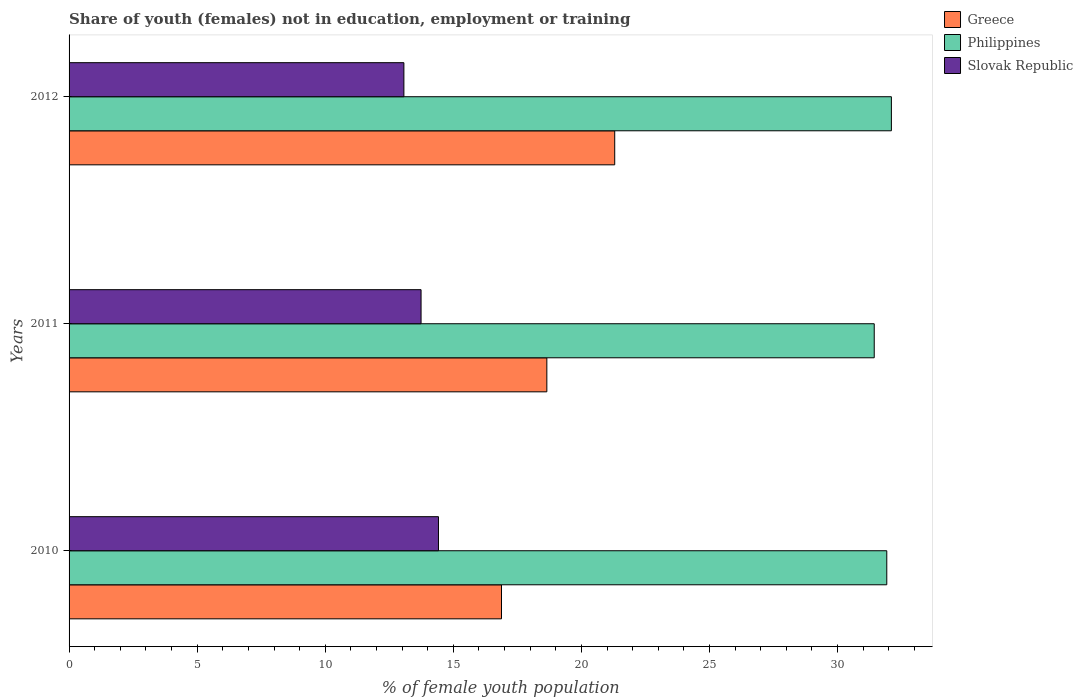How many groups of bars are there?
Make the answer very short. 3. Are the number of bars per tick equal to the number of legend labels?
Ensure brevity in your answer.  Yes. How many bars are there on the 3rd tick from the top?
Offer a very short reply. 3. How many bars are there on the 1st tick from the bottom?
Your answer should be compact. 3. In how many cases, is the number of bars for a given year not equal to the number of legend labels?
Provide a short and direct response. 0. What is the percentage of unemployed female population in in Slovak Republic in 2010?
Give a very brief answer. 14.42. Across all years, what is the maximum percentage of unemployed female population in in Slovak Republic?
Your answer should be very brief. 14.42. Across all years, what is the minimum percentage of unemployed female population in in Philippines?
Provide a succinct answer. 31.43. In which year was the percentage of unemployed female population in in Philippines maximum?
Make the answer very short. 2012. In which year was the percentage of unemployed female population in in Greece minimum?
Offer a terse response. 2010. What is the total percentage of unemployed female population in in Philippines in the graph?
Provide a short and direct response. 95.45. What is the difference between the percentage of unemployed female population in in Slovak Republic in 2010 and that in 2011?
Provide a short and direct response. 0.68. What is the difference between the percentage of unemployed female population in in Slovak Republic in 2011 and the percentage of unemployed female population in in Greece in 2012?
Give a very brief answer. -7.56. What is the average percentage of unemployed female population in in Greece per year?
Your answer should be very brief. 18.94. In the year 2011, what is the difference between the percentage of unemployed female population in in Greece and percentage of unemployed female population in in Slovak Republic?
Provide a short and direct response. 4.91. What is the ratio of the percentage of unemployed female population in in Philippines in 2010 to that in 2012?
Make the answer very short. 0.99. Is the percentage of unemployed female population in in Philippines in 2011 less than that in 2012?
Offer a terse response. Yes. Is the difference between the percentage of unemployed female population in in Greece in 2010 and 2012 greater than the difference between the percentage of unemployed female population in in Slovak Republic in 2010 and 2012?
Offer a very short reply. No. What is the difference between the highest and the second highest percentage of unemployed female population in in Slovak Republic?
Offer a very short reply. 0.68. What is the difference between the highest and the lowest percentage of unemployed female population in in Philippines?
Provide a short and direct response. 0.67. Is the sum of the percentage of unemployed female population in in Slovak Republic in 2010 and 2011 greater than the maximum percentage of unemployed female population in in Philippines across all years?
Offer a very short reply. No. What does the 2nd bar from the top in 2011 represents?
Give a very brief answer. Philippines. What does the 1st bar from the bottom in 2011 represents?
Provide a succinct answer. Greece. How many bars are there?
Offer a terse response. 9. Are all the bars in the graph horizontal?
Keep it short and to the point. Yes. Does the graph contain grids?
Your response must be concise. No. Where does the legend appear in the graph?
Offer a very short reply. Top right. What is the title of the graph?
Provide a succinct answer. Share of youth (females) not in education, employment or training. Does "Upper middle income" appear as one of the legend labels in the graph?
Provide a succinct answer. No. What is the label or title of the X-axis?
Provide a succinct answer. % of female youth population. What is the label or title of the Y-axis?
Make the answer very short. Years. What is the % of female youth population of Greece in 2010?
Ensure brevity in your answer.  16.88. What is the % of female youth population in Philippines in 2010?
Offer a terse response. 31.92. What is the % of female youth population of Slovak Republic in 2010?
Offer a terse response. 14.42. What is the % of female youth population of Greece in 2011?
Your answer should be compact. 18.65. What is the % of female youth population in Philippines in 2011?
Keep it short and to the point. 31.43. What is the % of female youth population of Slovak Republic in 2011?
Offer a very short reply. 13.74. What is the % of female youth population of Greece in 2012?
Offer a terse response. 21.3. What is the % of female youth population in Philippines in 2012?
Offer a terse response. 32.1. What is the % of female youth population of Slovak Republic in 2012?
Offer a terse response. 13.07. Across all years, what is the maximum % of female youth population in Greece?
Keep it short and to the point. 21.3. Across all years, what is the maximum % of female youth population of Philippines?
Make the answer very short. 32.1. Across all years, what is the maximum % of female youth population in Slovak Republic?
Provide a succinct answer. 14.42. Across all years, what is the minimum % of female youth population of Greece?
Keep it short and to the point. 16.88. Across all years, what is the minimum % of female youth population of Philippines?
Provide a succinct answer. 31.43. Across all years, what is the minimum % of female youth population in Slovak Republic?
Offer a terse response. 13.07. What is the total % of female youth population of Greece in the graph?
Provide a short and direct response. 56.83. What is the total % of female youth population in Philippines in the graph?
Offer a terse response. 95.45. What is the total % of female youth population of Slovak Republic in the graph?
Provide a short and direct response. 41.23. What is the difference between the % of female youth population in Greece in 2010 and that in 2011?
Your answer should be very brief. -1.77. What is the difference between the % of female youth population in Philippines in 2010 and that in 2011?
Offer a very short reply. 0.49. What is the difference between the % of female youth population in Slovak Republic in 2010 and that in 2011?
Give a very brief answer. 0.68. What is the difference between the % of female youth population in Greece in 2010 and that in 2012?
Provide a short and direct response. -4.42. What is the difference between the % of female youth population of Philippines in 2010 and that in 2012?
Keep it short and to the point. -0.18. What is the difference between the % of female youth population in Slovak Republic in 2010 and that in 2012?
Your response must be concise. 1.35. What is the difference between the % of female youth population of Greece in 2011 and that in 2012?
Make the answer very short. -2.65. What is the difference between the % of female youth population in Philippines in 2011 and that in 2012?
Provide a succinct answer. -0.67. What is the difference between the % of female youth population of Slovak Republic in 2011 and that in 2012?
Offer a very short reply. 0.67. What is the difference between the % of female youth population of Greece in 2010 and the % of female youth population of Philippines in 2011?
Provide a succinct answer. -14.55. What is the difference between the % of female youth population of Greece in 2010 and the % of female youth population of Slovak Republic in 2011?
Offer a terse response. 3.14. What is the difference between the % of female youth population of Philippines in 2010 and the % of female youth population of Slovak Republic in 2011?
Your answer should be compact. 18.18. What is the difference between the % of female youth population of Greece in 2010 and the % of female youth population of Philippines in 2012?
Your response must be concise. -15.22. What is the difference between the % of female youth population in Greece in 2010 and the % of female youth population in Slovak Republic in 2012?
Ensure brevity in your answer.  3.81. What is the difference between the % of female youth population of Philippines in 2010 and the % of female youth population of Slovak Republic in 2012?
Provide a succinct answer. 18.85. What is the difference between the % of female youth population of Greece in 2011 and the % of female youth population of Philippines in 2012?
Offer a very short reply. -13.45. What is the difference between the % of female youth population of Greece in 2011 and the % of female youth population of Slovak Republic in 2012?
Provide a short and direct response. 5.58. What is the difference between the % of female youth population in Philippines in 2011 and the % of female youth population in Slovak Republic in 2012?
Offer a terse response. 18.36. What is the average % of female youth population of Greece per year?
Make the answer very short. 18.94. What is the average % of female youth population of Philippines per year?
Your response must be concise. 31.82. What is the average % of female youth population in Slovak Republic per year?
Keep it short and to the point. 13.74. In the year 2010, what is the difference between the % of female youth population in Greece and % of female youth population in Philippines?
Provide a succinct answer. -15.04. In the year 2010, what is the difference between the % of female youth population of Greece and % of female youth population of Slovak Republic?
Make the answer very short. 2.46. In the year 2010, what is the difference between the % of female youth population of Philippines and % of female youth population of Slovak Republic?
Your answer should be compact. 17.5. In the year 2011, what is the difference between the % of female youth population in Greece and % of female youth population in Philippines?
Your response must be concise. -12.78. In the year 2011, what is the difference between the % of female youth population in Greece and % of female youth population in Slovak Republic?
Your answer should be compact. 4.91. In the year 2011, what is the difference between the % of female youth population of Philippines and % of female youth population of Slovak Republic?
Provide a succinct answer. 17.69. In the year 2012, what is the difference between the % of female youth population of Greece and % of female youth population of Philippines?
Ensure brevity in your answer.  -10.8. In the year 2012, what is the difference between the % of female youth population of Greece and % of female youth population of Slovak Republic?
Provide a short and direct response. 8.23. In the year 2012, what is the difference between the % of female youth population of Philippines and % of female youth population of Slovak Republic?
Keep it short and to the point. 19.03. What is the ratio of the % of female youth population of Greece in 2010 to that in 2011?
Provide a succinct answer. 0.91. What is the ratio of the % of female youth population in Philippines in 2010 to that in 2011?
Your answer should be compact. 1.02. What is the ratio of the % of female youth population of Slovak Republic in 2010 to that in 2011?
Give a very brief answer. 1.05. What is the ratio of the % of female youth population in Greece in 2010 to that in 2012?
Offer a very short reply. 0.79. What is the ratio of the % of female youth population in Philippines in 2010 to that in 2012?
Your answer should be compact. 0.99. What is the ratio of the % of female youth population in Slovak Republic in 2010 to that in 2012?
Offer a terse response. 1.1. What is the ratio of the % of female youth population of Greece in 2011 to that in 2012?
Offer a terse response. 0.88. What is the ratio of the % of female youth population of Philippines in 2011 to that in 2012?
Keep it short and to the point. 0.98. What is the ratio of the % of female youth population of Slovak Republic in 2011 to that in 2012?
Make the answer very short. 1.05. What is the difference between the highest and the second highest % of female youth population in Greece?
Offer a terse response. 2.65. What is the difference between the highest and the second highest % of female youth population of Philippines?
Your answer should be compact. 0.18. What is the difference between the highest and the second highest % of female youth population of Slovak Republic?
Make the answer very short. 0.68. What is the difference between the highest and the lowest % of female youth population in Greece?
Keep it short and to the point. 4.42. What is the difference between the highest and the lowest % of female youth population in Philippines?
Offer a terse response. 0.67. What is the difference between the highest and the lowest % of female youth population of Slovak Republic?
Your answer should be compact. 1.35. 